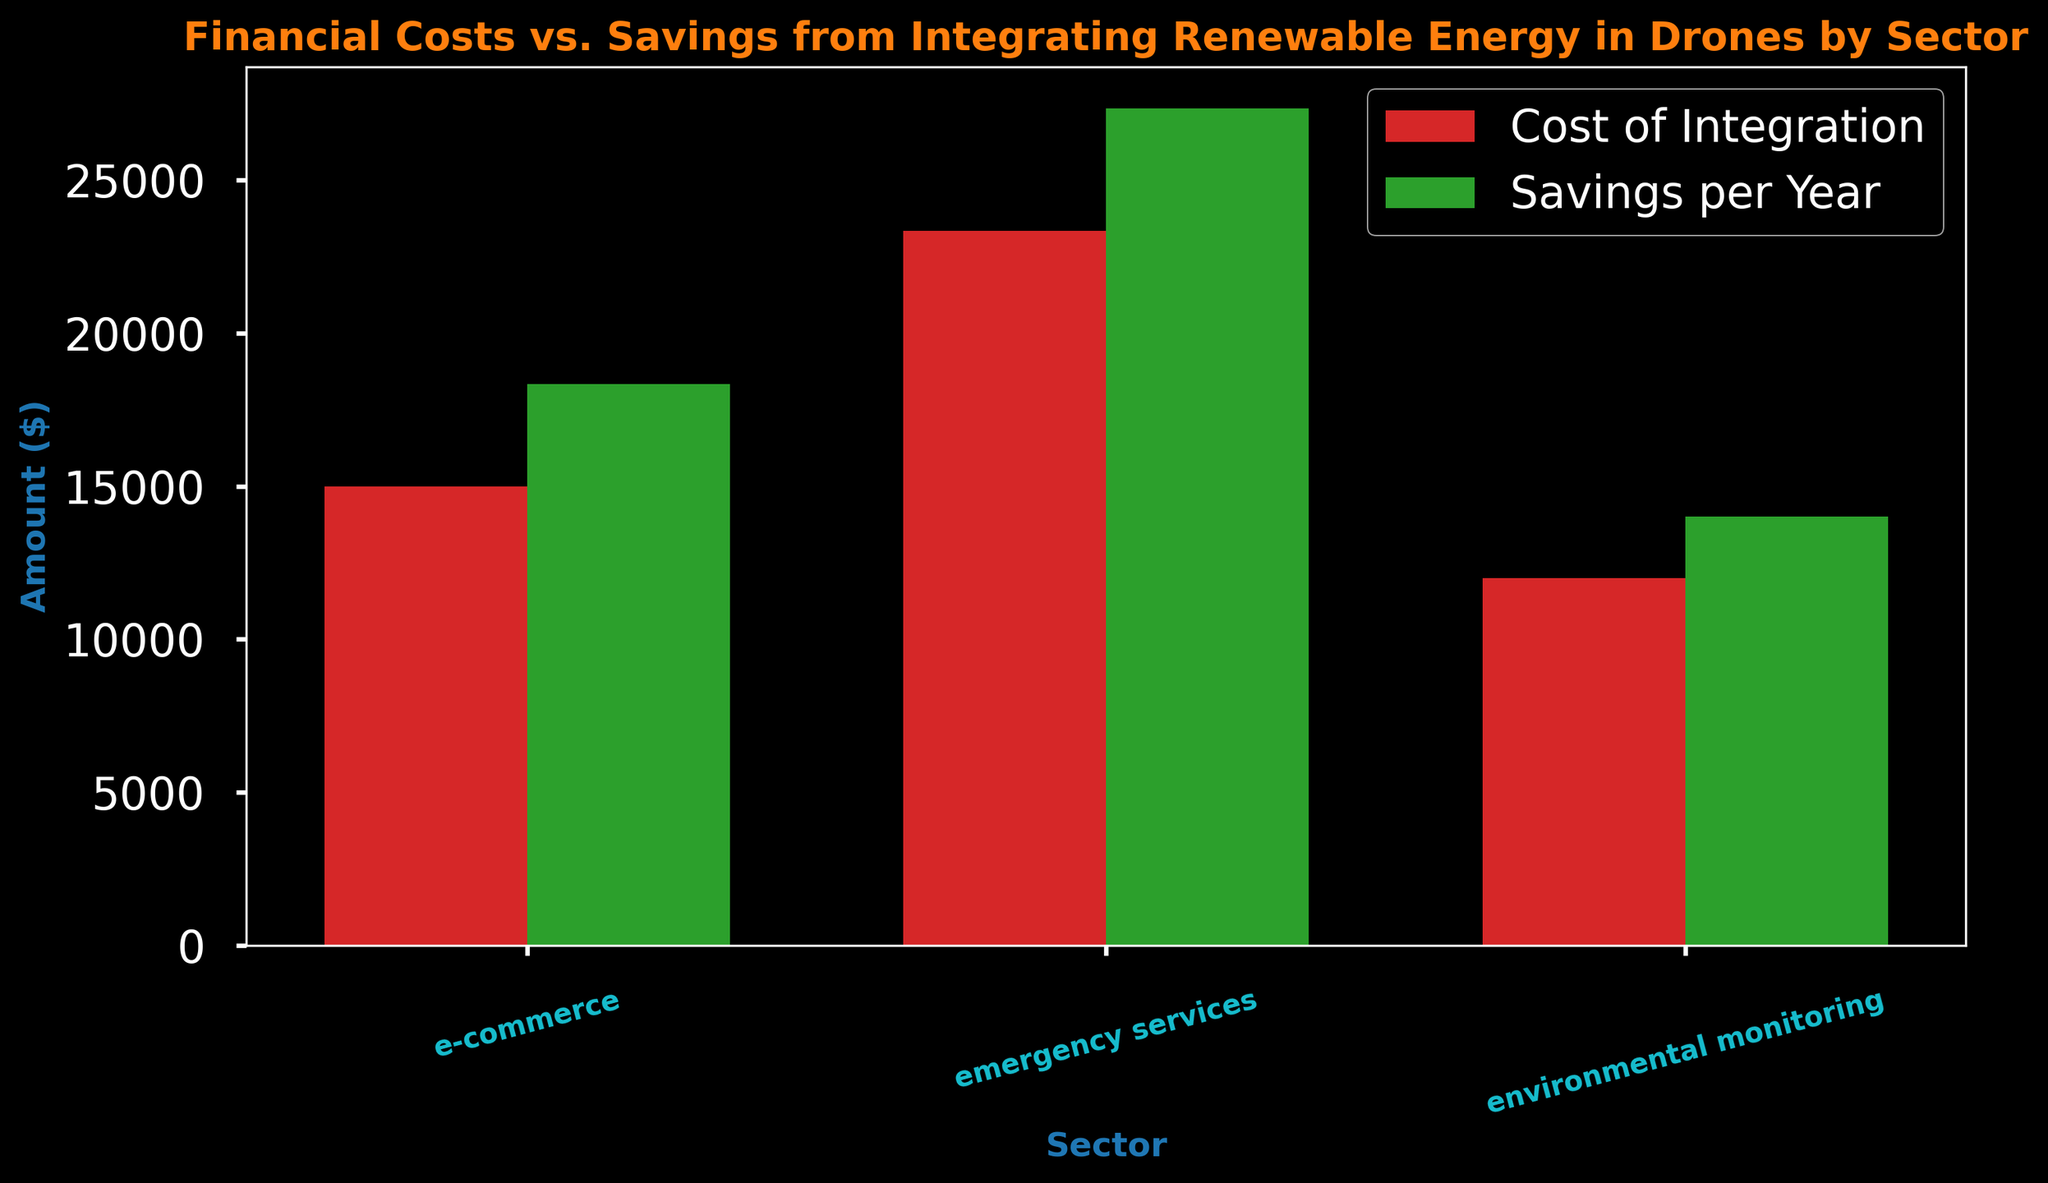What's the average cost of integration for the emergency services sector? The figure shows the average costs for each sector. Locate the bar representing the emergency services sector in red and read its height.
Answer: 23,333.33 Which sector has the highest average savings per year? The figure includes green bars representing average savings per year for each sector. The tallest green bar indicates the highest average savings. Compare the heights of the green bars across sectors.
Answer: Emergency services What is the difference between the average cost of integration and average savings per year for environmental monitoring? Find the red and green bars corresponding to the environmental monitoring sector. Subtract the average cost of integration (height of the red bar) from the average savings per year (height of the green bar).
Answer: 2,000 Are the average savings per year for e-commerce greater than the average costs of integration for the same sector? Compare the height of the green bar (average savings) to the height of the adjacent red bar (average costs) for the e-commerce sector.
Answer: Yes Which sector enjoys the largest net savings (savings per year minus cost of integration)? For each sector, subtract the height of the red bar from the height of the green bar. Compare these differences across the sectors to determine the largest net savings.
Answer: Emergency services Is the average cost of integration for environmental monitoring less than that for emergency services? Locate the red bars for both environmental monitoring and emergency services. Compare their heights to assess if the environmental monitoring bar is shorter (indicating a lower cost).
Answer: Yes What is the combined average savings per year for all sectors? Sum the heights of the green bars (average savings) for e-commerce, emergency services, and environmental monitoring to get the total average savings.
Answer: 24,666.67 Which sector has the lowest average cost of integration? Identify the shortest red bar representing average costs among all sectors.
Answer: Environmental monitoring By how much do the average yearly savings exceed the average costs of integration for the emergency services sector? Subtract the height of the red bar (cost) from the height of the green bar (savings) for the emergency services sector.
Answer: 5,000 What color represents the average costs of integration in the plot? The figure uses different colors to represent average costs and savings. Identify the color used for average integration costs.
Answer: Red 